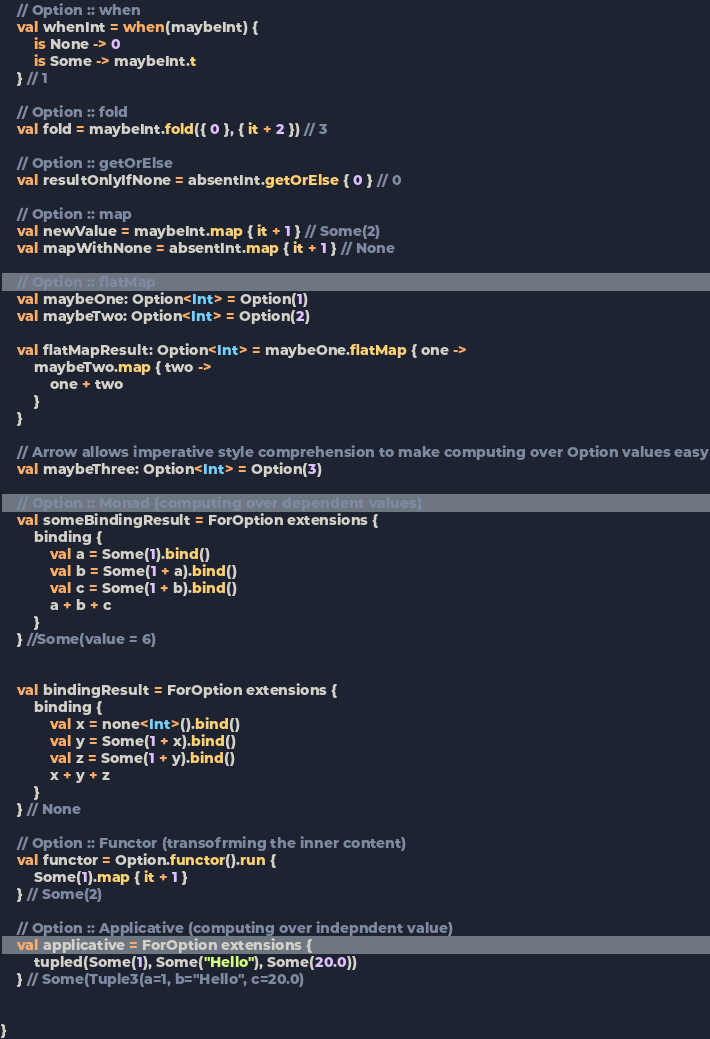Convert code to text. <code><loc_0><loc_0><loc_500><loc_500><_Kotlin_>
    // Option :: when
    val whenInt = when(maybeInt) {
        is None -> 0
        is Some -> maybeInt.t
    } // 1

    // Option :: fold
    val fold = maybeInt.fold({ 0 }, { it + 2 }) // 3

    // Option :: getOrElse
    val resultOnlyIfNone = absentInt.getOrElse { 0 } // 0

    // Option :: map
    val newValue = maybeInt.map { it + 1 } // Some(2)
    val mapWithNone = absentInt.map { it + 1 } // None

    // Option :: flatMap
    val maybeOne: Option<Int> = Option(1)
    val maybeTwo: Option<Int> = Option(2)

    val flatMapResult: Option<Int> = maybeOne.flatMap { one ->
        maybeTwo.map { two ->
            one + two
        }
    }

    // Arrow allows imperative style comprehension to make computing over Option values easy
    val maybeThree: Option<Int> = Option(3)

    // Option :: Monad (computing over dependent values)
    val someBindingResult = ForOption extensions {
        binding {
            val a = Some(1).bind()
            val b = Some(1 + a).bind()
            val c = Some(1 + b).bind()
            a + b + c
        }
    } //Some(value = 6)


    val bindingResult = ForOption extensions {
        binding {
            val x = none<Int>().bind()
            val y = Some(1 + x).bind()
            val z = Some(1 + y).bind()
            x + y + z
        }
    } // None

    // Option :: Functor (transofrming the inner content)
    val functor = Option.functor().run {
        Some(1).map { it + 1 }
    } // Some(2)

    // Option :: Applicative (computing over indepndent value)
    val applicative = ForOption extensions {
        tupled(Some(1), Some("Hello"), Some(20.0))
    } // Some(Tuple3(a=1, b="Hello", c=20.0)


}</code> 